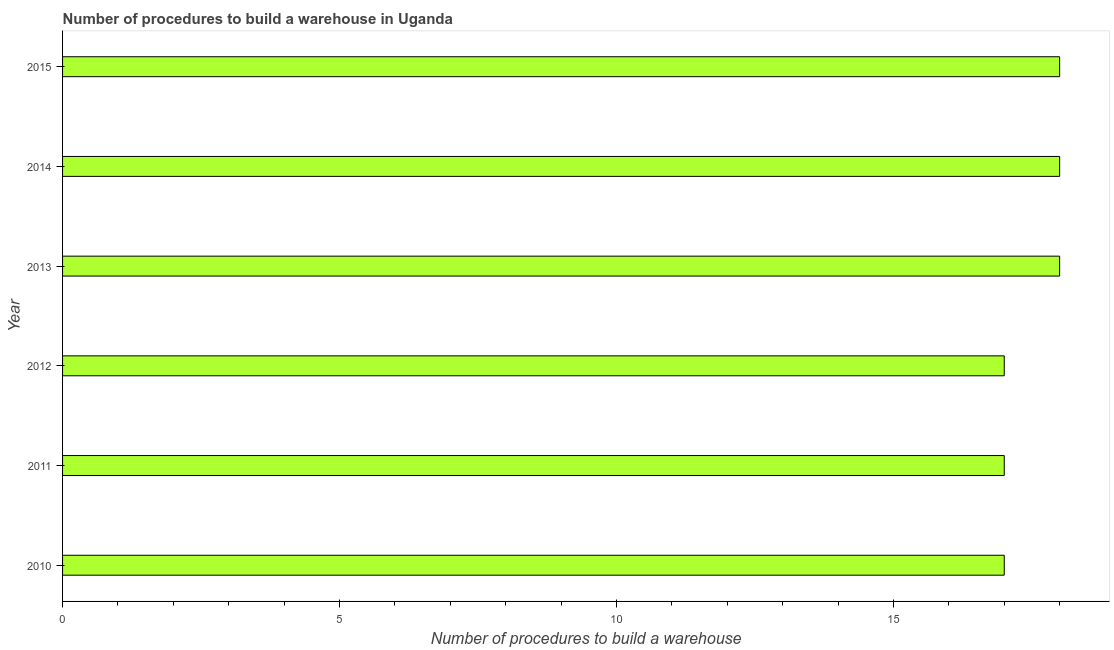Does the graph contain any zero values?
Provide a short and direct response. No. What is the title of the graph?
Provide a short and direct response. Number of procedures to build a warehouse in Uganda. What is the label or title of the X-axis?
Your answer should be compact. Number of procedures to build a warehouse. Across all years, what is the minimum number of procedures to build a warehouse?
Offer a terse response. 17. In which year was the number of procedures to build a warehouse minimum?
Give a very brief answer. 2010. What is the sum of the number of procedures to build a warehouse?
Provide a succinct answer. 105. What is the median number of procedures to build a warehouse?
Your answer should be very brief. 17.5. Do a majority of the years between 2011 and 2010 (inclusive) have number of procedures to build a warehouse greater than 9 ?
Offer a very short reply. No. What is the ratio of the number of procedures to build a warehouse in 2011 to that in 2012?
Ensure brevity in your answer.  1. Is the difference between the number of procedures to build a warehouse in 2011 and 2012 greater than the difference between any two years?
Offer a very short reply. No. What is the difference between the highest and the lowest number of procedures to build a warehouse?
Offer a very short reply. 1. In how many years, is the number of procedures to build a warehouse greater than the average number of procedures to build a warehouse taken over all years?
Ensure brevity in your answer.  3. How many bars are there?
Offer a very short reply. 6. What is the difference between two consecutive major ticks on the X-axis?
Provide a short and direct response. 5. Are the values on the major ticks of X-axis written in scientific E-notation?
Offer a terse response. No. What is the Number of procedures to build a warehouse in 2011?
Your response must be concise. 17. What is the Number of procedures to build a warehouse in 2012?
Offer a terse response. 17. What is the Number of procedures to build a warehouse in 2013?
Provide a short and direct response. 18. What is the Number of procedures to build a warehouse of 2014?
Make the answer very short. 18. What is the Number of procedures to build a warehouse in 2015?
Offer a terse response. 18. What is the difference between the Number of procedures to build a warehouse in 2010 and 2011?
Keep it short and to the point. 0. What is the difference between the Number of procedures to build a warehouse in 2010 and 2012?
Ensure brevity in your answer.  0. What is the difference between the Number of procedures to build a warehouse in 2011 and 2012?
Offer a terse response. 0. What is the difference between the Number of procedures to build a warehouse in 2011 and 2013?
Your answer should be compact. -1. What is the difference between the Number of procedures to build a warehouse in 2012 and 2013?
Keep it short and to the point. -1. What is the difference between the Number of procedures to build a warehouse in 2012 and 2014?
Your answer should be compact. -1. What is the difference between the Number of procedures to build a warehouse in 2012 and 2015?
Make the answer very short. -1. What is the difference between the Number of procedures to build a warehouse in 2013 and 2015?
Provide a short and direct response. 0. What is the ratio of the Number of procedures to build a warehouse in 2010 to that in 2012?
Keep it short and to the point. 1. What is the ratio of the Number of procedures to build a warehouse in 2010 to that in 2013?
Ensure brevity in your answer.  0.94. What is the ratio of the Number of procedures to build a warehouse in 2010 to that in 2014?
Make the answer very short. 0.94. What is the ratio of the Number of procedures to build a warehouse in 2010 to that in 2015?
Provide a short and direct response. 0.94. What is the ratio of the Number of procedures to build a warehouse in 2011 to that in 2012?
Keep it short and to the point. 1. What is the ratio of the Number of procedures to build a warehouse in 2011 to that in 2013?
Make the answer very short. 0.94. What is the ratio of the Number of procedures to build a warehouse in 2011 to that in 2014?
Give a very brief answer. 0.94. What is the ratio of the Number of procedures to build a warehouse in 2011 to that in 2015?
Give a very brief answer. 0.94. What is the ratio of the Number of procedures to build a warehouse in 2012 to that in 2013?
Provide a short and direct response. 0.94. What is the ratio of the Number of procedures to build a warehouse in 2012 to that in 2014?
Keep it short and to the point. 0.94. What is the ratio of the Number of procedures to build a warehouse in 2012 to that in 2015?
Offer a terse response. 0.94. What is the ratio of the Number of procedures to build a warehouse in 2013 to that in 2014?
Provide a short and direct response. 1. What is the ratio of the Number of procedures to build a warehouse in 2014 to that in 2015?
Give a very brief answer. 1. 